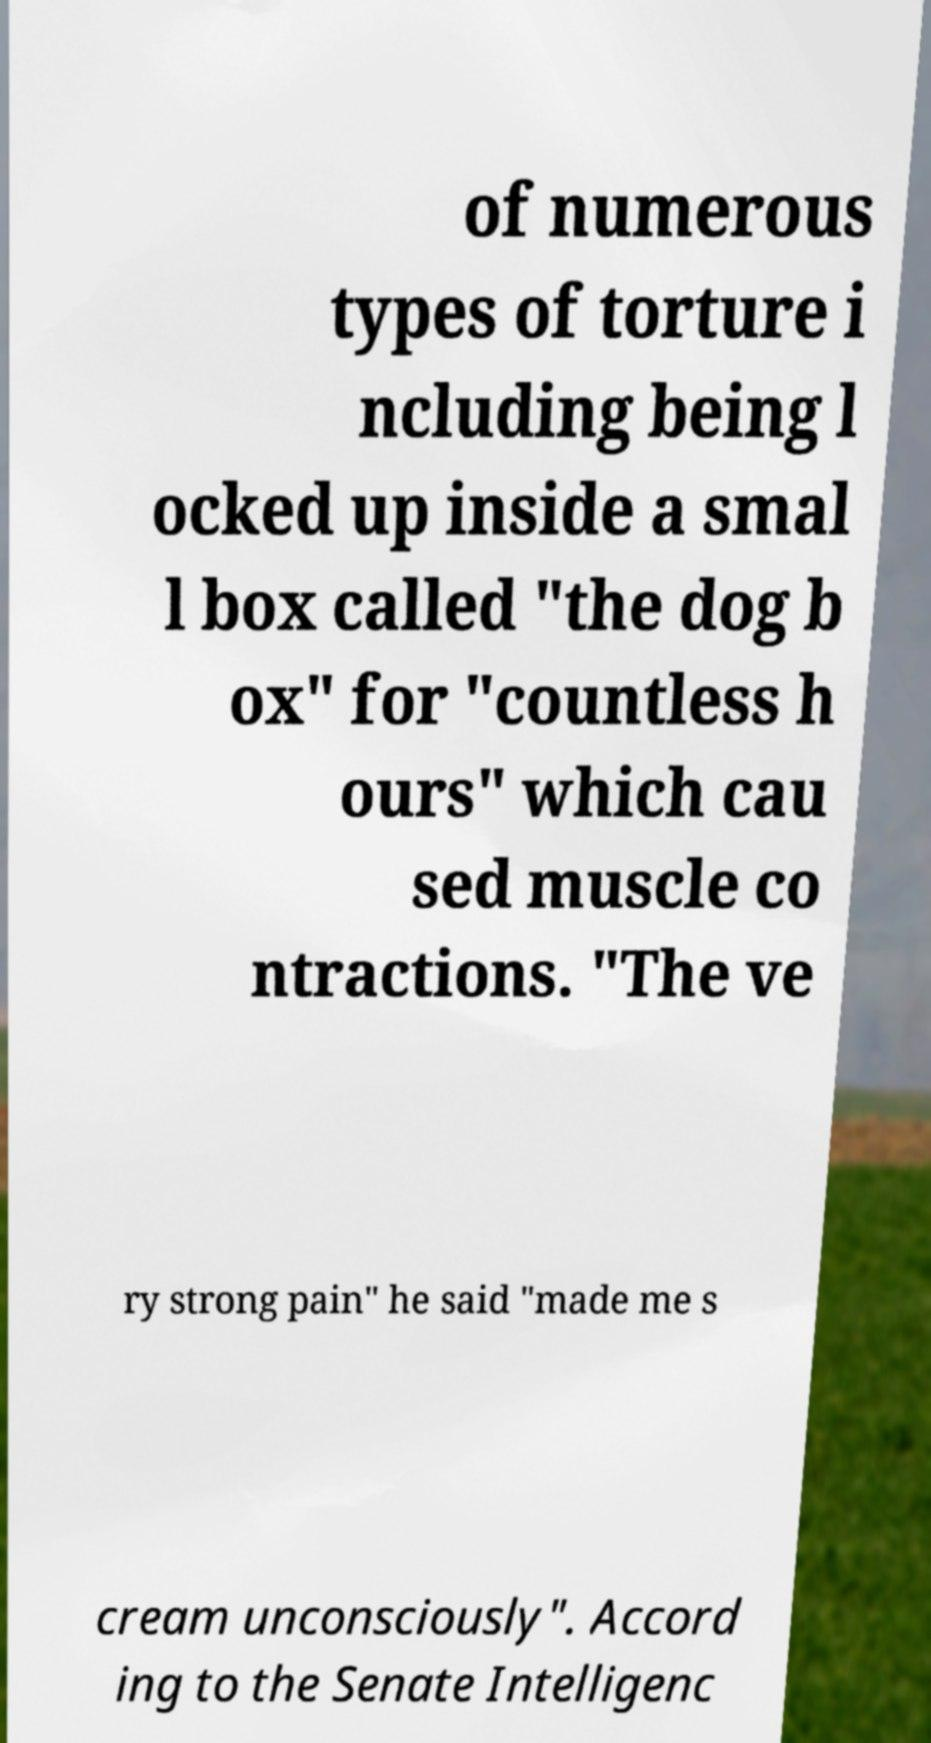Can you read and provide the text displayed in the image?This photo seems to have some interesting text. Can you extract and type it out for me? of numerous types of torture i ncluding being l ocked up inside a smal l box called "the dog b ox" for "countless h ours" which cau sed muscle co ntractions. "The ve ry strong pain" he said "made me s cream unconsciously". Accord ing to the Senate Intelligenc 